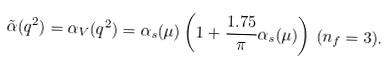Convert formula to latex. <formula><loc_0><loc_0><loc_500><loc_500>\tilde { \alpha } ( q ^ { 2 } ) = \alpha _ { V } ( q ^ { 2 } ) = \alpha _ { s } ( \mu ) \left ( 1 + \frac { 1 . 7 5 } { \pi } \alpha _ { s } ( \mu ) \right ) \, ( n _ { f } = 3 ) .</formula> 